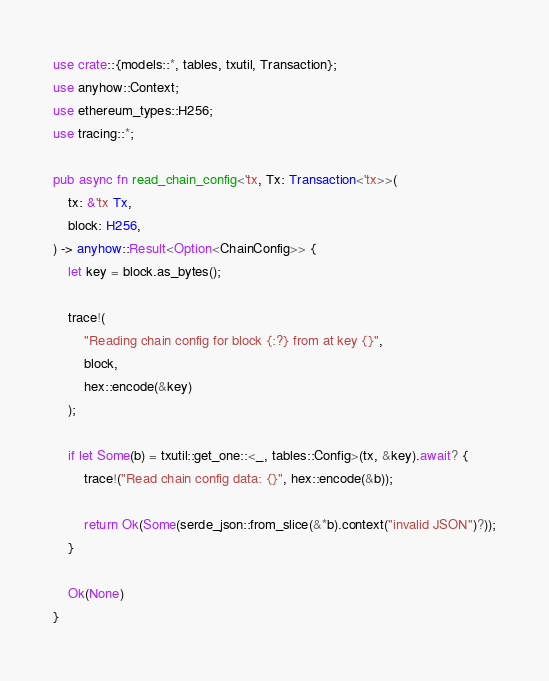Convert code to text. <code><loc_0><loc_0><loc_500><loc_500><_Rust_>use crate::{models::*, tables, txutil, Transaction};
use anyhow::Context;
use ethereum_types::H256;
use tracing::*;

pub async fn read_chain_config<'tx, Tx: Transaction<'tx>>(
    tx: &'tx Tx,
    block: H256,
) -> anyhow::Result<Option<ChainConfig>> {
    let key = block.as_bytes();

    trace!(
        "Reading chain config for block {:?} from at key {}",
        block,
        hex::encode(&key)
    );

    if let Some(b) = txutil::get_one::<_, tables::Config>(tx, &key).await? {
        trace!("Read chain config data: {}", hex::encode(&b));

        return Ok(Some(serde_json::from_slice(&*b).context("invalid JSON")?));
    }

    Ok(None)
}
</code> 